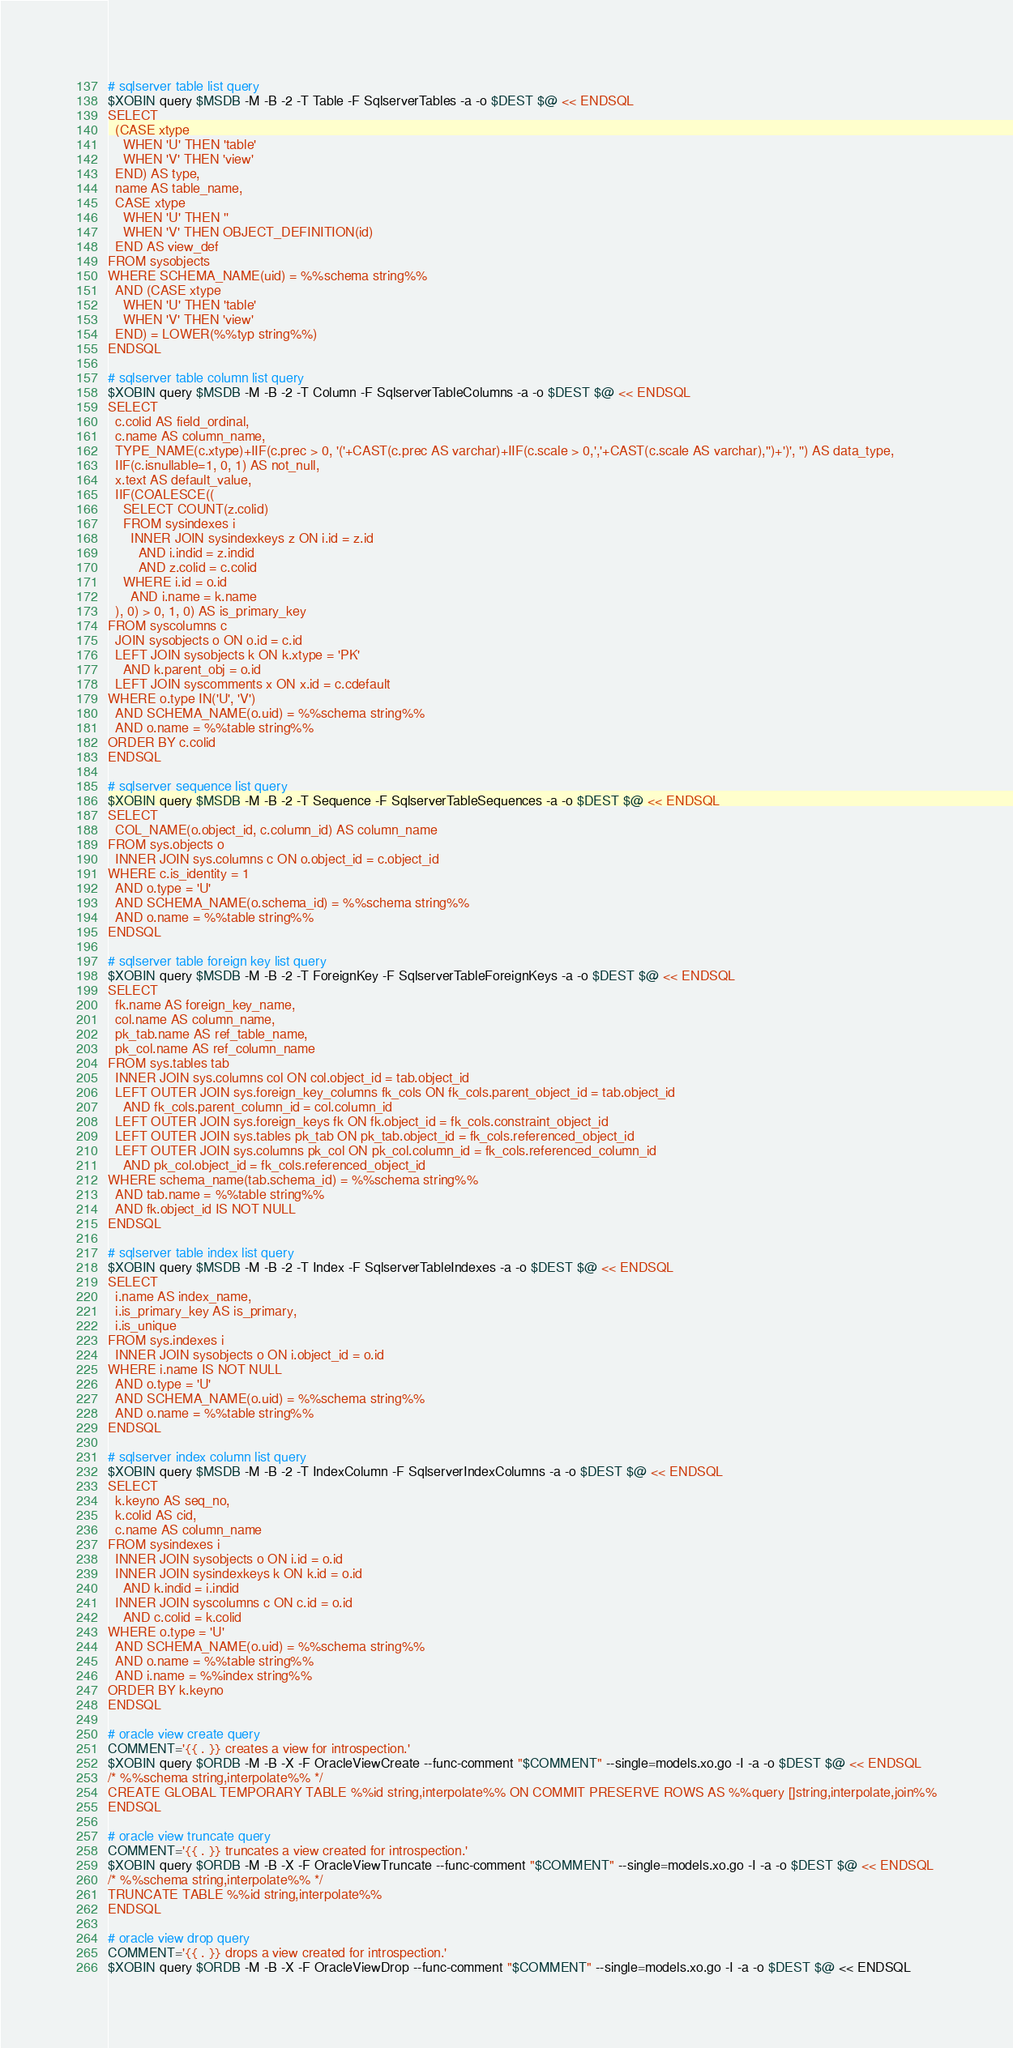<code> <loc_0><loc_0><loc_500><loc_500><_Bash_>
# sqlserver table list query
$XOBIN query $MSDB -M -B -2 -T Table -F SqlserverTables -a -o $DEST $@ << ENDSQL
SELECT
  (CASE xtype
    WHEN 'U' THEN 'table'
    WHEN 'V' THEN 'view'
  END) AS type,
  name AS table_name,
  CASE xtype
    WHEN 'U' THEN ''
    WHEN 'V' THEN OBJECT_DEFINITION(id)
  END AS view_def
FROM sysobjects
WHERE SCHEMA_NAME(uid) = %%schema string%%
  AND (CASE xtype
    WHEN 'U' THEN 'table'
    WHEN 'V' THEN 'view'
  END) = LOWER(%%typ string%%)
ENDSQL

# sqlserver table column list query
$XOBIN query $MSDB -M -B -2 -T Column -F SqlserverTableColumns -a -o $DEST $@ << ENDSQL
SELECT
  c.colid AS field_ordinal,
  c.name AS column_name,
  TYPE_NAME(c.xtype)+IIF(c.prec > 0, '('+CAST(c.prec AS varchar)+IIF(c.scale > 0,','+CAST(c.scale AS varchar),'')+')', '') AS data_type,
  IIF(c.isnullable=1, 0, 1) AS not_null,
  x.text AS default_value,
  IIF(COALESCE((
    SELECT COUNT(z.colid)
    FROM sysindexes i
      INNER JOIN sysindexkeys z ON i.id = z.id
        AND i.indid = z.indid
        AND z.colid = c.colid
    WHERE i.id = o.id
      AND i.name = k.name
  ), 0) > 0, 1, 0) AS is_primary_key
FROM syscolumns c
  JOIN sysobjects o ON o.id = c.id
  LEFT JOIN sysobjects k ON k.xtype = 'PK'
    AND k.parent_obj = o.id
  LEFT JOIN syscomments x ON x.id = c.cdefault
WHERE o.type IN('U', 'V')
  AND SCHEMA_NAME(o.uid) = %%schema string%%
  AND o.name = %%table string%%
ORDER BY c.colid
ENDSQL

# sqlserver sequence list query
$XOBIN query $MSDB -M -B -2 -T Sequence -F SqlserverTableSequences -a -o $DEST $@ << ENDSQL
SELECT
  COL_NAME(o.object_id, c.column_id) AS column_name
FROM sys.objects o
  INNER JOIN sys.columns c ON o.object_id = c.object_id
WHERE c.is_identity = 1
  AND o.type = 'U'
  AND SCHEMA_NAME(o.schema_id) = %%schema string%%
  AND o.name = %%table string%%
ENDSQL

# sqlserver table foreign key list query
$XOBIN query $MSDB -M -B -2 -T ForeignKey -F SqlserverTableForeignKeys -a -o $DEST $@ << ENDSQL
SELECT
  fk.name AS foreign_key_name,
  col.name AS column_name,
  pk_tab.name AS ref_table_name,
  pk_col.name AS ref_column_name
FROM sys.tables tab
  INNER JOIN sys.columns col ON col.object_id = tab.object_id
  LEFT OUTER JOIN sys.foreign_key_columns fk_cols ON fk_cols.parent_object_id = tab.object_id
    AND fk_cols.parent_column_id = col.column_id
  LEFT OUTER JOIN sys.foreign_keys fk ON fk.object_id = fk_cols.constraint_object_id
  LEFT OUTER JOIN sys.tables pk_tab ON pk_tab.object_id = fk_cols.referenced_object_id
  LEFT OUTER JOIN sys.columns pk_col ON pk_col.column_id = fk_cols.referenced_column_id
    AND pk_col.object_id = fk_cols.referenced_object_id
WHERE schema_name(tab.schema_id) = %%schema string%%
  AND tab.name = %%table string%%
  AND fk.object_id IS NOT NULL
ENDSQL

# sqlserver table index list query
$XOBIN query $MSDB -M -B -2 -T Index -F SqlserverTableIndexes -a -o $DEST $@ << ENDSQL
SELECT
  i.name AS index_name,
  i.is_primary_key AS is_primary,
  i.is_unique
FROM sys.indexes i
  INNER JOIN sysobjects o ON i.object_id = o.id
WHERE i.name IS NOT NULL
  AND o.type = 'U'
  AND SCHEMA_NAME(o.uid) = %%schema string%%
  AND o.name = %%table string%%
ENDSQL

# sqlserver index column list query
$XOBIN query $MSDB -M -B -2 -T IndexColumn -F SqlserverIndexColumns -a -o $DEST $@ << ENDSQL
SELECT
  k.keyno AS seq_no,
  k.colid AS cid,
  c.name AS column_name
FROM sysindexes i
  INNER JOIN sysobjects o ON i.id = o.id
  INNER JOIN sysindexkeys k ON k.id = o.id
    AND k.indid = i.indid
  INNER JOIN syscolumns c ON c.id = o.id
    AND c.colid = k.colid
WHERE o.type = 'U'
  AND SCHEMA_NAME(o.uid) = %%schema string%%
  AND o.name = %%table string%%
  AND i.name = %%index string%%
ORDER BY k.keyno
ENDSQL

# oracle view create query
COMMENT='{{ . }} creates a view for introspection.'
$XOBIN query $ORDB -M -B -X -F OracleViewCreate --func-comment "$COMMENT" --single=models.xo.go -I -a -o $DEST $@ << ENDSQL
/* %%schema string,interpolate%% */
CREATE GLOBAL TEMPORARY TABLE %%id string,interpolate%% ON COMMIT PRESERVE ROWS AS %%query []string,interpolate,join%%
ENDSQL

# oracle view truncate query
COMMENT='{{ . }} truncates a view created for introspection.'
$XOBIN query $ORDB -M -B -X -F OracleViewTruncate --func-comment "$COMMENT" --single=models.xo.go -I -a -o $DEST $@ << ENDSQL
/* %%schema string,interpolate%% */
TRUNCATE TABLE %%id string,interpolate%%
ENDSQL

# oracle view drop query
COMMENT='{{ . }} drops a view created for introspection.'
$XOBIN query $ORDB -M -B -X -F OracleViewDrop --func-comment "$COMMENT" --single=models.xo.go -I -a -o $DEST $@ << ENDSQL</code> 